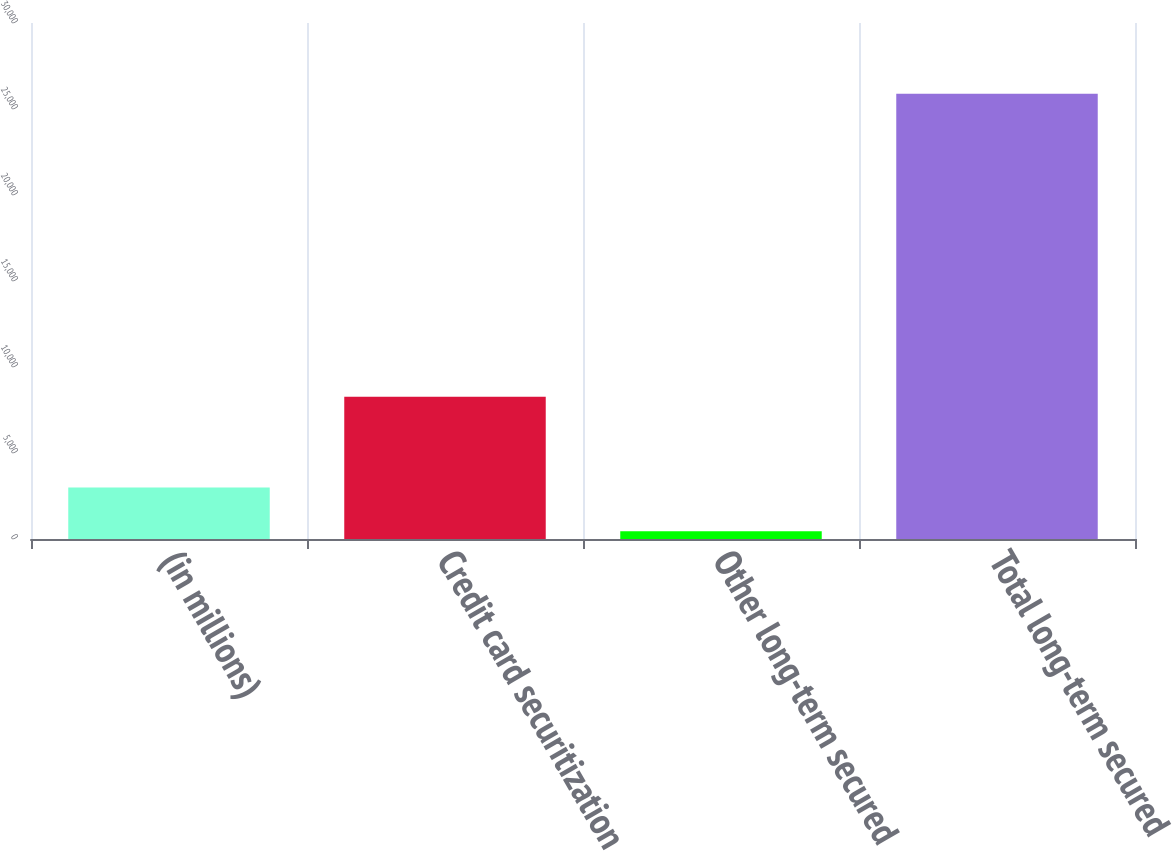Convert chart to OTSL. <chart><loc_0><loc_0><loc_500><loc_500><bar_chart><fcel>(in millions)<fcel>Credit card securitization<fcel>Other long-term secured<fcel>Total long-term secured<nl><fcel>2997.7<fcel>8277<fcel>455<fcel>25882<nl></chart> 